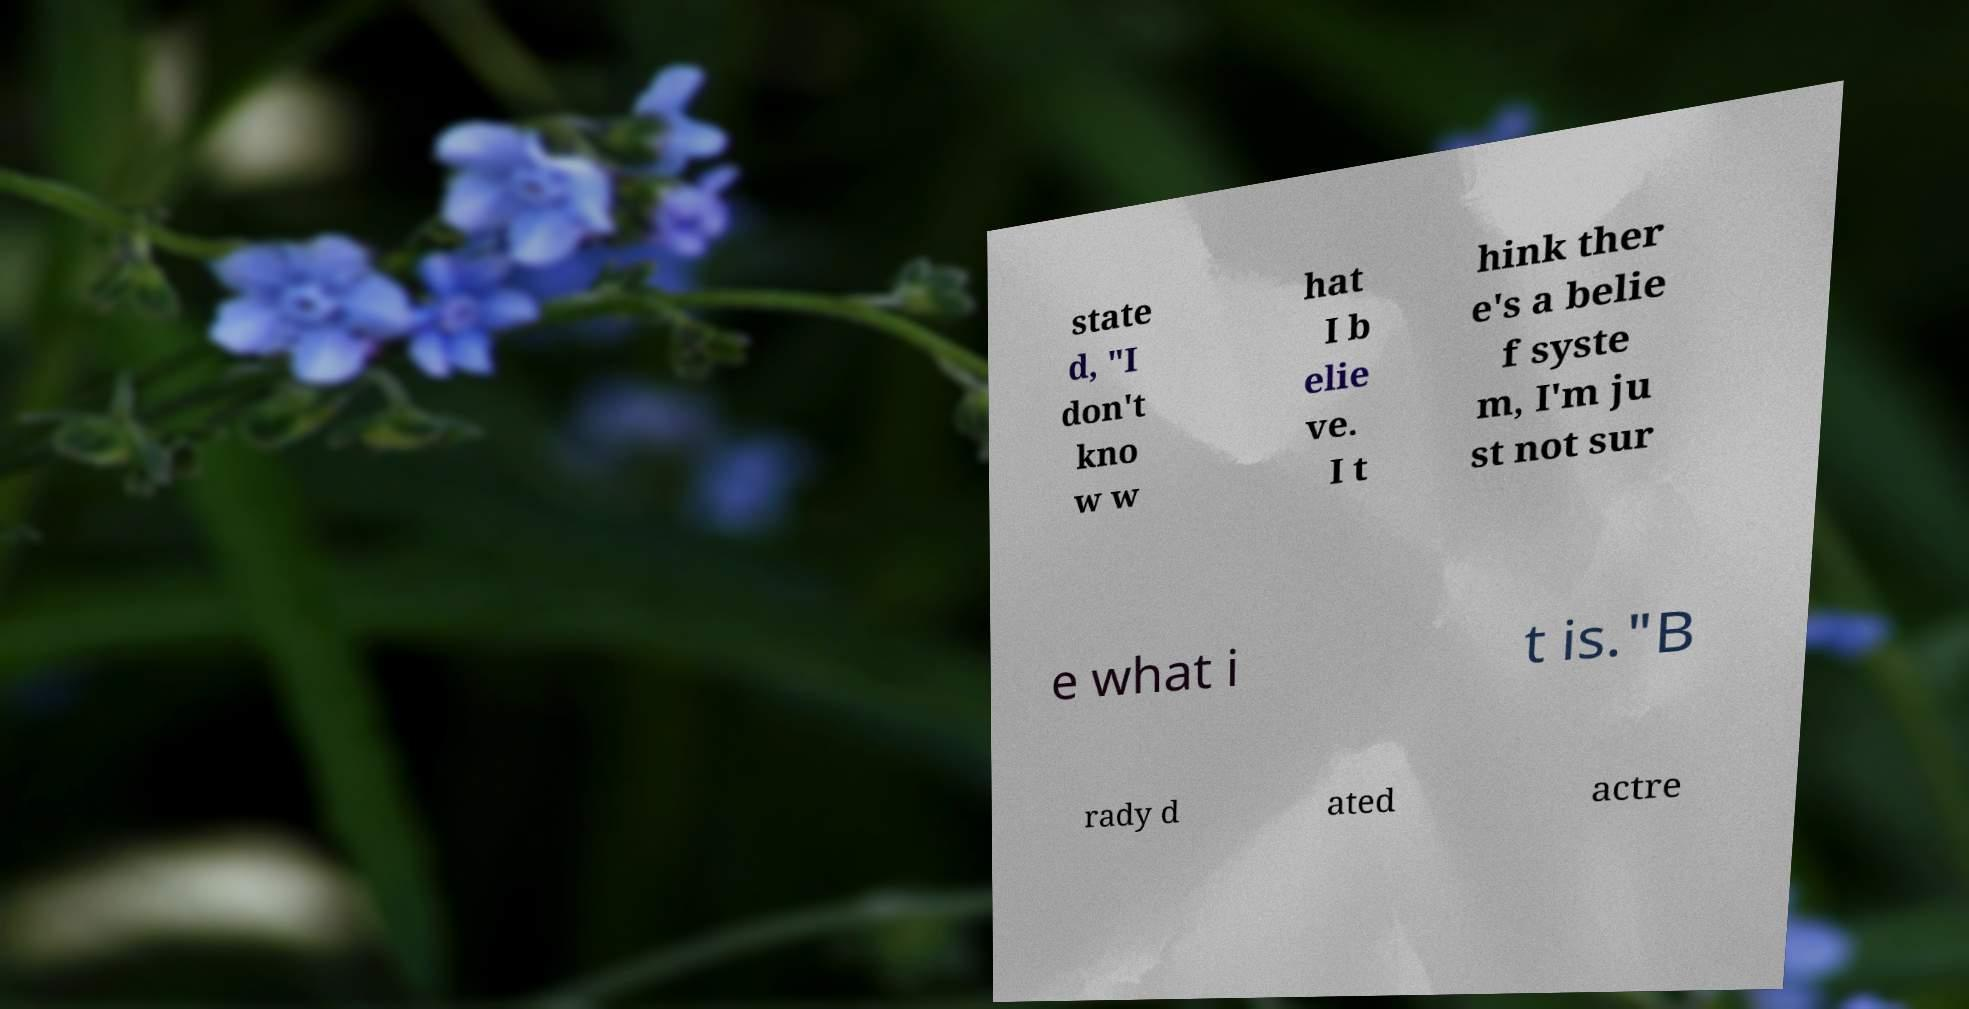Please identify and transcribe the text found in this image. state d, "I don't kno w w hat I b elie ve. I t hink ther e's a belie f syste m, I'm ju st not sur e what i t is."B rady d ated actre 